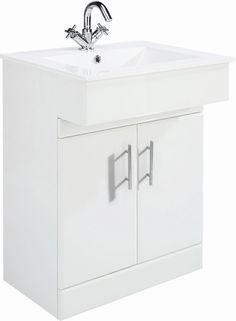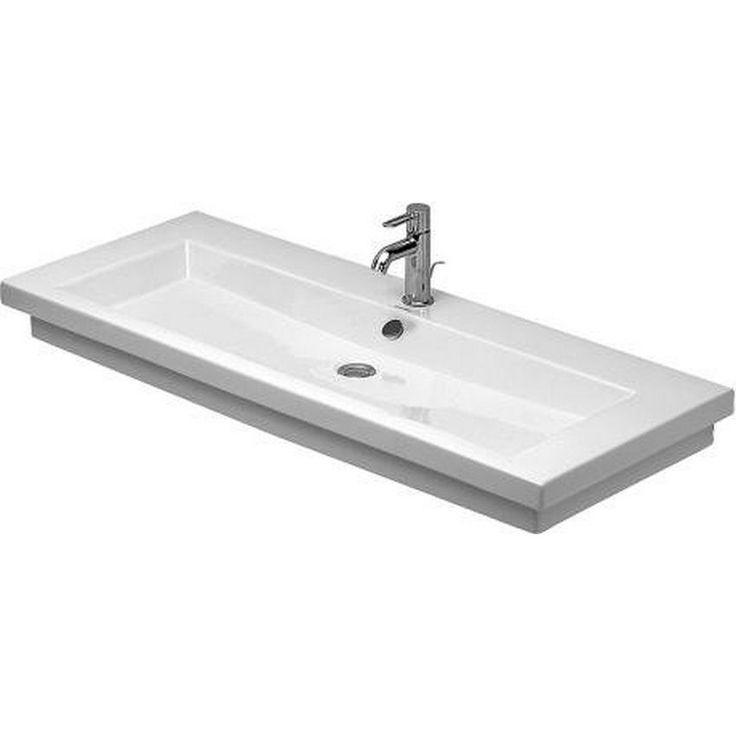The first image is the image on the left, the second image is the image on the right. For the images shown, is this caption "There is a square white sink with single faucet on top and cabinet underneath." true? Answer yes or no. Yes. The first image is the image on the left, the second image is the image on the right. Given the left and right images, does the statement "The sink in one image has a soap dispenser." hold true? Answer yes or no. No. 